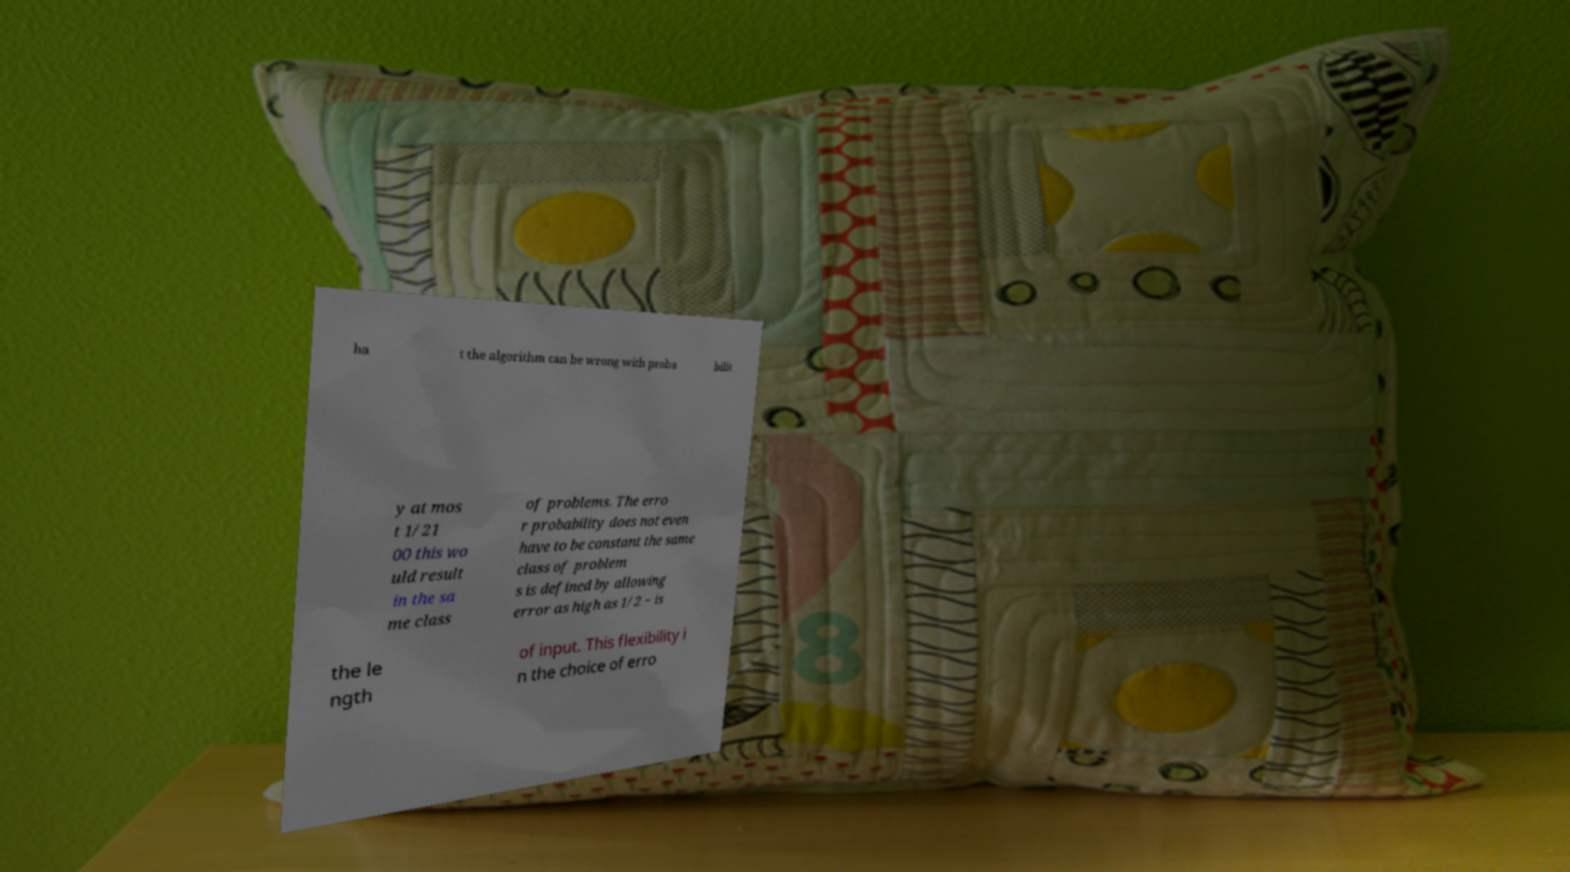There's text embedded in this image that I need extracted. Can you transcribe it verbatim? ha t the algorithm can be wrong with proba bilit y at mos t 1/21 00 this wo uld result in the sa me class of problems. The erro r probability does not even have to be constant the same class of problem s is defined by allowing error as high as 1/2 − is the le ngth of input. This flexibility i n the choice of erro 